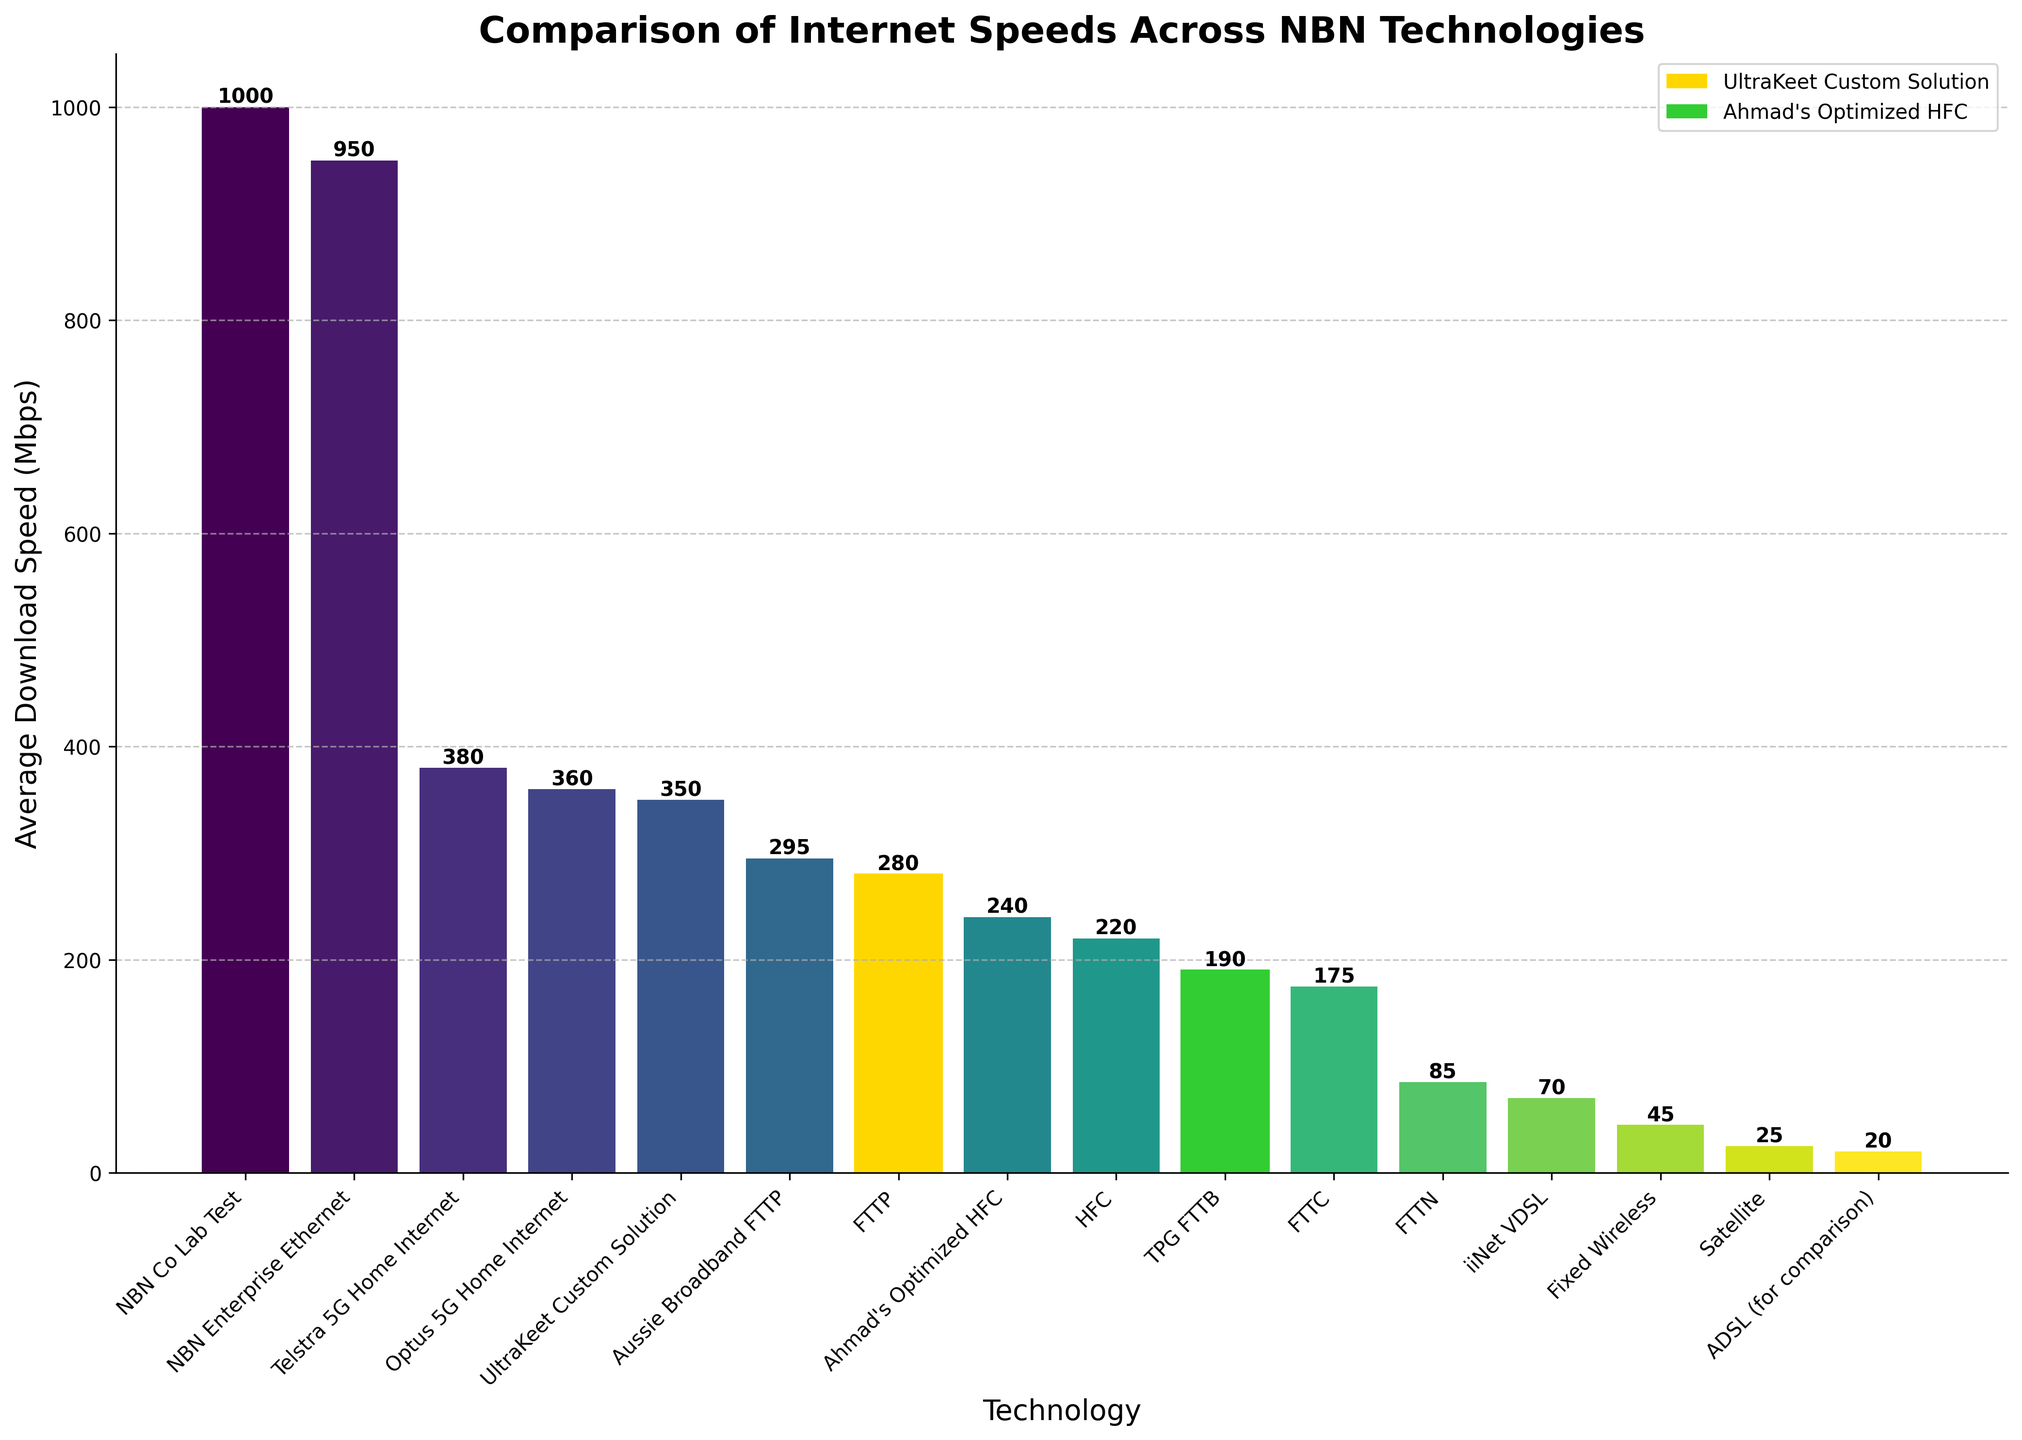Which technology has the highest average download speed? The technology with the highest average download speed can be identified by observing the tallest bar on the plot. The tallest bar corresponds to "NBN Co Lab Test".
Answer: NBN Co Lab Test How much faster is "Ahmad's Optimized HFC" compared to "FTTN"? To find this out, subtract the average download speed of "FTTN" from "Ahmad's Optimized HFC". "Ahmad's Optimized HFC" has a speed of 240 Mbps and "FTTN" has a speed of 85 Mbps. The difference is 240 - 85 = 155 Mbps.
Answer: 155 Mbps What is the combined average download speed of "FTTP" and "Aussie Broadband FTTP"? To determine this, add the average download speeds of "FTTP" and "Aussie Broadband FTTP". "FTTP" is 280 Mbps, and "Aussie Broadband FTTP" is 295 Mbps. The total is 280 + 295 = 575 Mbps.
Answer: 575 Mbps Which technology is faster: "Telstra 5G Home Internet" or "Optus 5G Home Internet"? Compare the heights of the bars for "Telstra 5G Home Internet" and "Optus 5G Home Internet". "Telstra 5G Home Internet" is 380 Mbps, whereas "Optus 5G Home Internet" is 360 Mbps. Therefore, "Telstra 5G Home Internet" is faster.
Answer: Telstra 5G Home Internet How does the speed of "UltraKeet Custom Solution" compare to the speed of "Ahmad's Optimized HFC"? Check the bar heights corresponding to both technologies. "UltraKeet Custom Solution" is 350 Mbps and "Ahmad's Optimized HFC" is 240 Mbps. "UltraKeet Custom Solution" is 350 - 240 = 110 Mbps faster.
Answer: 110 Mbps faster Among the traditional NBN technologies (HFC, FTTP, FTTN, Fixed Wireless, FTTC, Satellite), which one has the lowest average speed? Among the traditional NBN technologies, identify the shortest bar within the specified technologies. The shortest bar corresponds to "Satellite" with 25 Mbps.
Answer: Satellite If we consider both "NBN Co Lab Test" and "NBN Enterprise Ethernet", what is their average speed? To calculate the average speed, sum the speeds of "NBN Co Lab Test" and "NBN Enterprise Ethernet" and then divide by 2. "NBN Co Lab Test" is 1000 Mbps and "NBN Enterprise Ethernet" is 950 Mbps. (1000 + 950) / 2 = 975 Mbps.
Answer: 975 Mbps Which technology is highlighted in gold color? The gold-colored bar indicates the "UltraKeet Custom Solution", highlighted to emphasize its position.
Answer: UltraKeet Custom Solution What is the speed difference between "ADSL" and "Fixed Wireless"? To find the difference, subtract the speed of "ADSL" from "Fixed Wireless". "Fixed Wireless" has a speed of 45 Mbps, and "ADSL" has a speed of 20 Mbps. The difference is 45 - 20 = 25 Mbps.
Answer: 25 Mbps What is the median speed of the technologies listed in the figure? To find the median speed, first arrange all speeds in ascending order and then find the middle value. The ordered speeds are: 20, 25, 45, 70, 85, 175, 190, 220, 240, 280, 295, 350, 360, 380, 950, 1000. With 16 data points, the median is the average of the 8th and 9th values. The 8th and 9th values are 220 and 240. The median is (220 + 240) / 2 = 230 Mbps.
Answer: 230 Mbps 